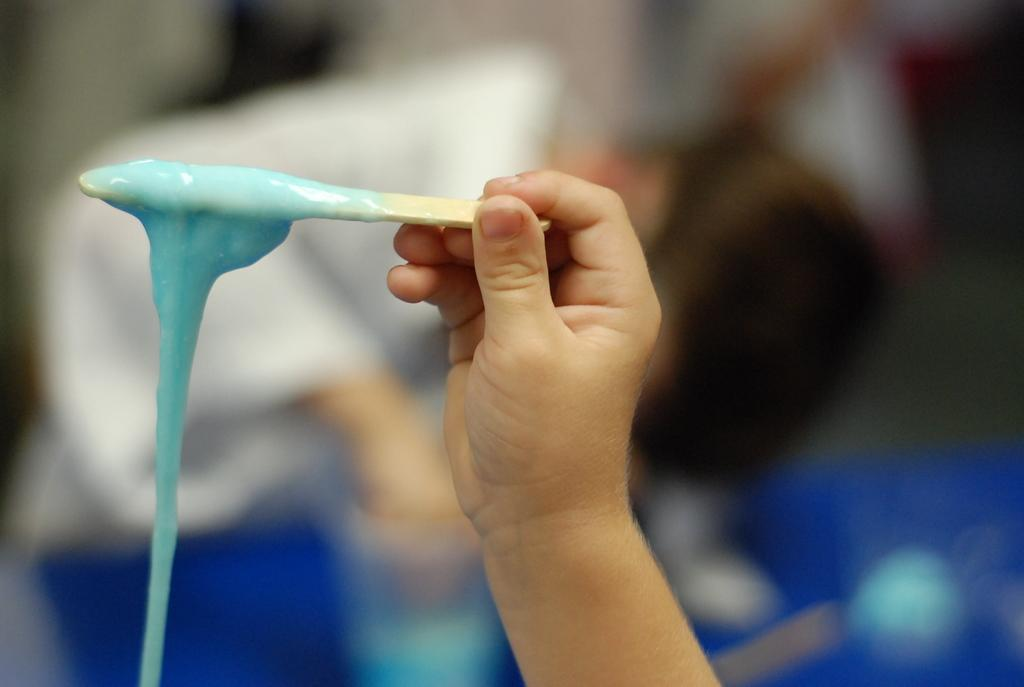What is the main subject of the image? The main subject of the image is a kid. What is the kid holding in their hands? The kid is holding a stick in their hands. Can you describe the background of the image? There are people in the background of the image. What type of blade is the kid using to cut the grass in the image? There is no blade or grass present in the image; the kid is holding a stick. 